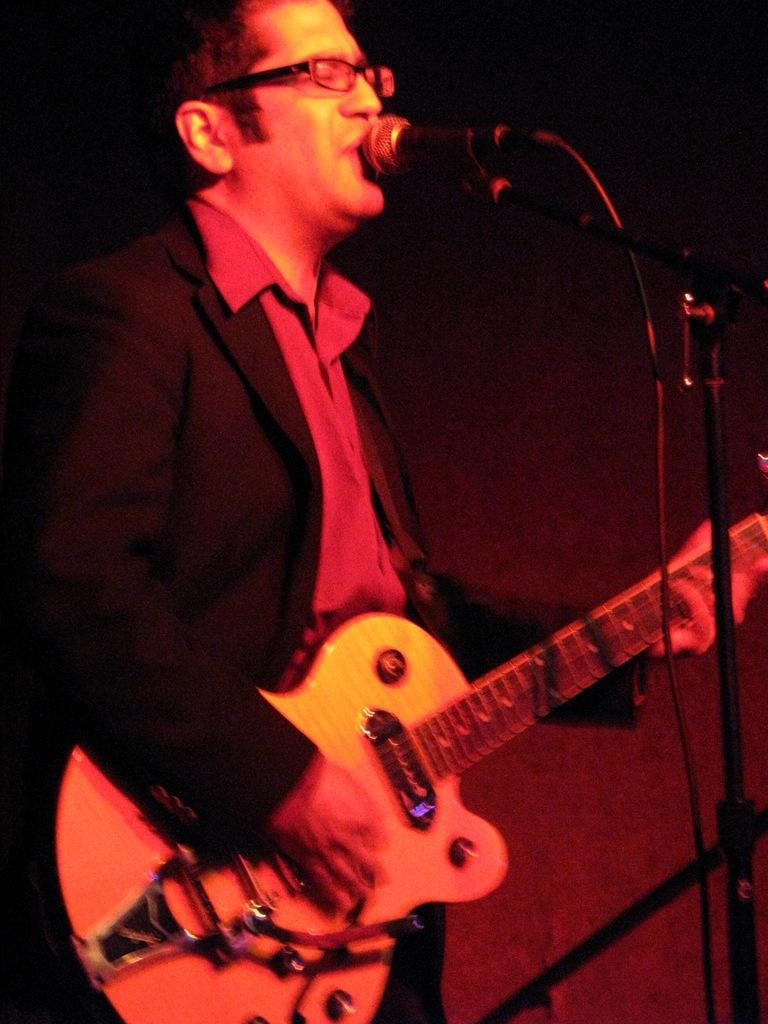What is the man in the image doing? The man is playing a guitar and singing. How is the man's voice being amplified in the image? The man is using a microphone. What type of paint is the man using to create a statement in the image? There is no paint or statement being made in the image; the man is playing a guitar and singing. 